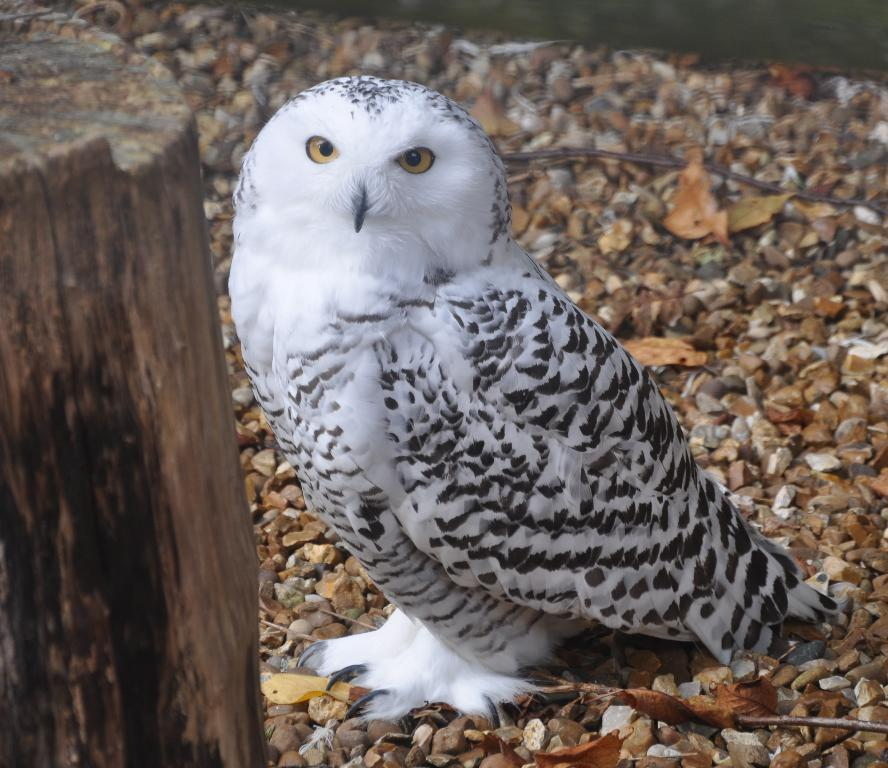What is the main subject in the center of the image? There is an owl in the center of the image. What can be seen on the left side of the image? There is a tree trunk on the left side of the image. How many books are stacked on the rail in the image? There are no books or rails present in the image. 